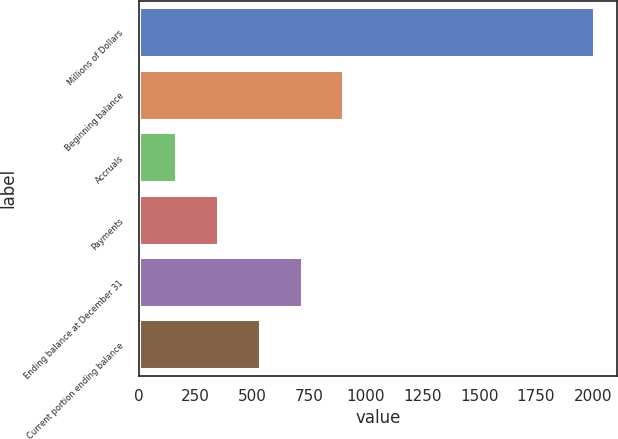Convert chart. <chart><loc_0><loc_0><loc_500><loc_500><bar_chart><fcel>Millions of Dollars<fcel>Beginning balance<fcel>Accruals<fcel>Payments<fcel>Ending balance at December 31<fcel>Current portion ending balance<nl><fcel>2007<fcel>901.8<fcel>165<fcel>349.2<fcel>717.6<fcel>533.4<nl></chart> 